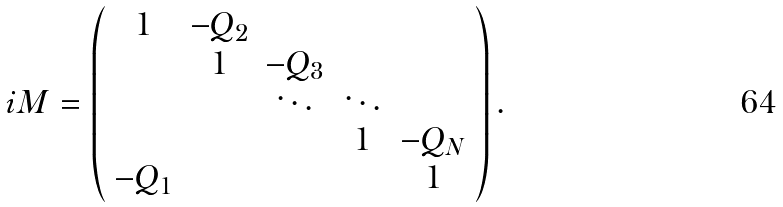Convert formula to latex. <formula><loc_0><loc_0><loc_500><loc_500>i M = \left ( \begin{array} { c c c c c } 1 & - Q _ { 2 } & & & \\ & 1 & - Q _ { 3 } & & \\ & & \ddots & \ddots & \\ & & & 1 & - Q _ { N } \\ - Q _ { 1 } & & & & 1 \end{array} \right ) .</formula> 